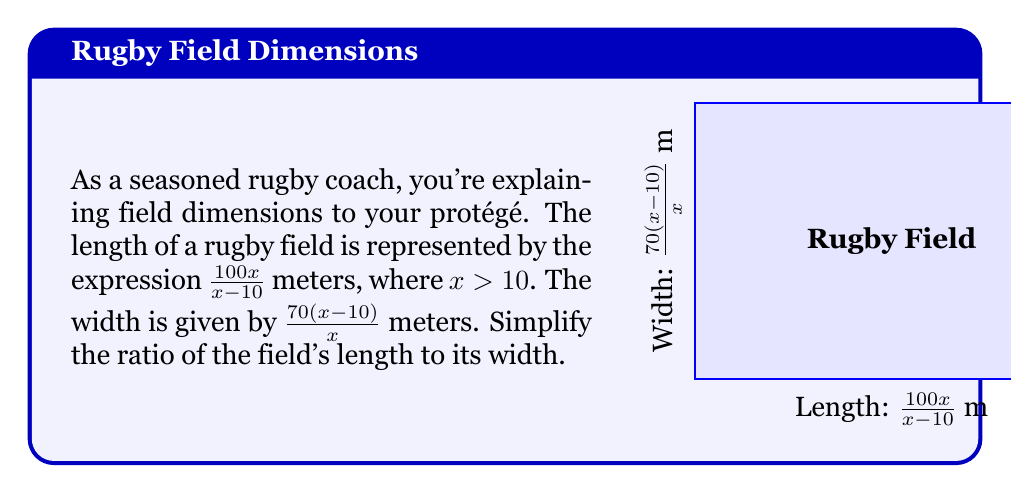Provide a solution to this math problem. Let's approach this step-by-step:

1) The ratio of length to width is:

   $$\frac{\text{Length}}{\text{Width}} = \frac{\frac{100x}{x-10}}{\frac{70(x-10)}{x}}$$

2) To divide fractions, we multiply by the reciprocal:

   $$\frac{\frac{100x}{x-10}}{\frac{70(x-10)}{x}} = \frac{100x}{x-10} \cdot \frac{x}{70(x-10)}$$

3) Now we can cancel out $(x-10)$ in the numerator and denominator:

   $$\frac{100x}{x-10} \cdot \frac{x}{70(x-10)} = \frac{100x}{70} \cdot \frac{x}{x-10}$$

4) Multiply the numerators and denominators:

   $$\frac{100x^2}{70(x-10)}$$

5) Simplify by dividing both numerator and denominator by 10:

   $$\frac{10x^2}{7(x-10)}$$

This is the simplified ratio of the field's length to its width.
Answer: $\frac{10x^2}{7(x-10)}$ 